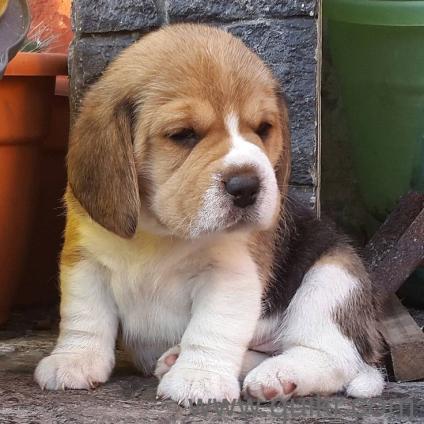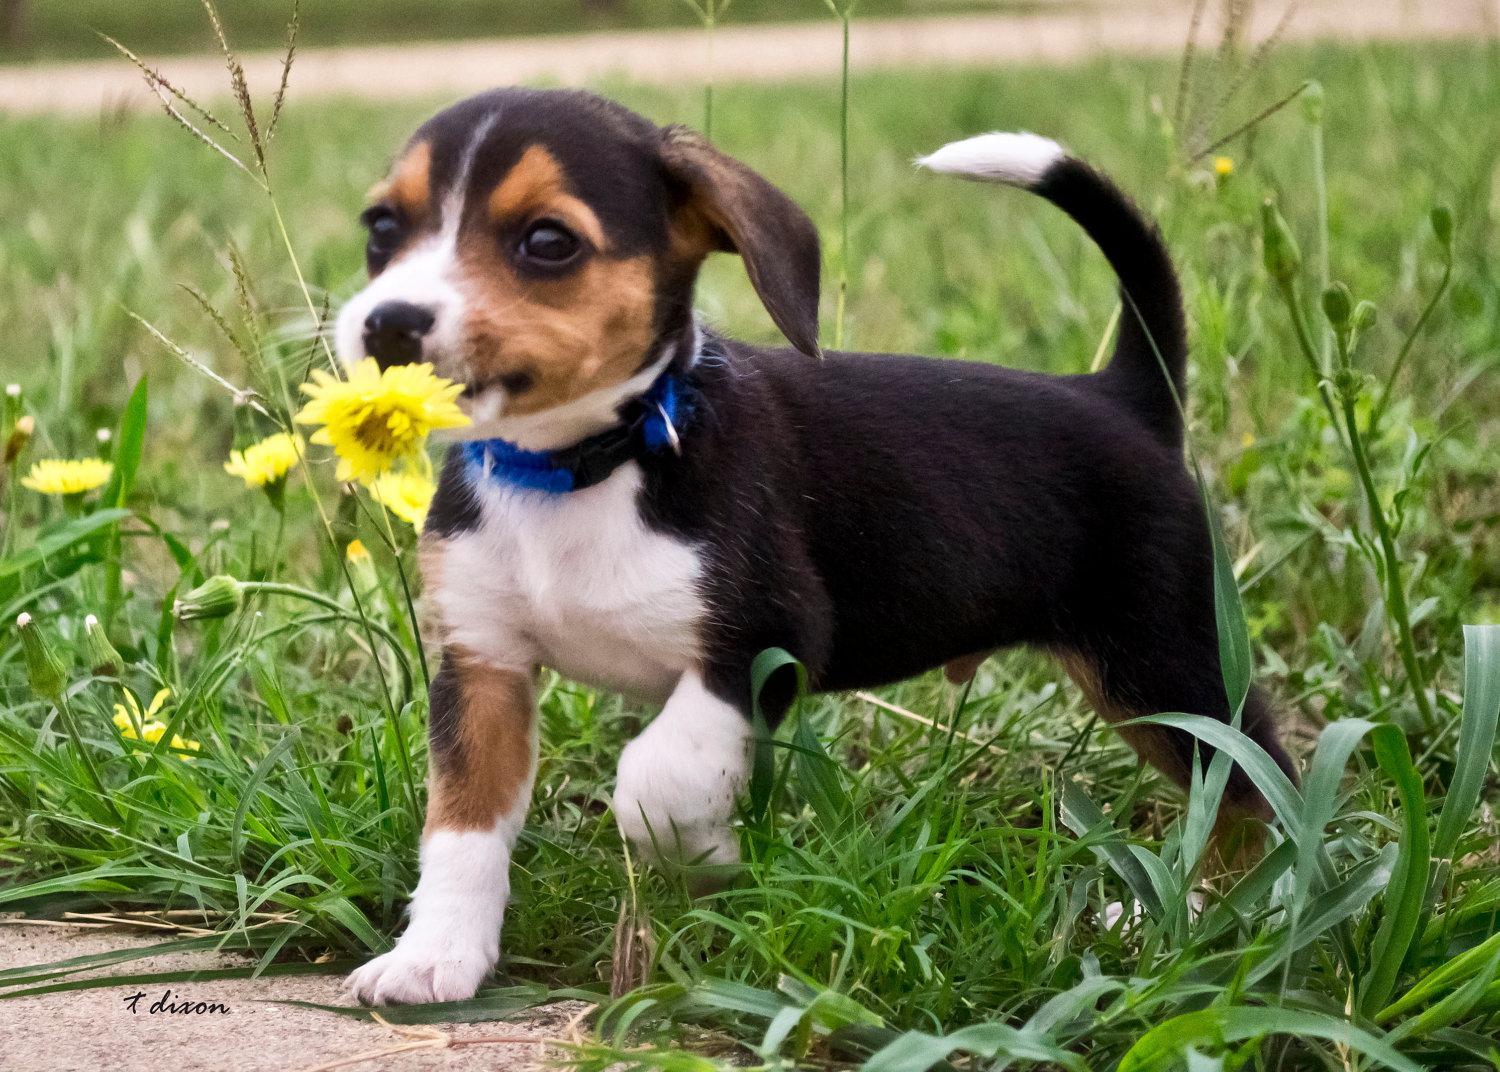The first image is the image on the left, the second image is the image on the right. For the images displayed, is the sentence "Each image contains one dog, and one image shows a sitting puppy while the other shows a tri-color beagle wearing something around its neck." factually correct? Answer yes or no. Yes. The first image is the image on the left, the second image is the image on the right. For the images shown, is this caption "Exactly one dog in the right image is standing." true? Answer yes or no. Yes. 